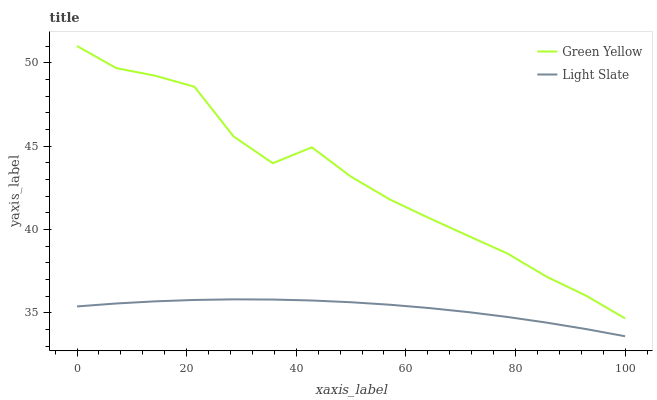Does Light Slate have the minimum area under the curve?
Answer yes or no. Yes. Does Green Yellow have the maximum area under the curve?
Answer yes or no. Yes. Does Green Yellow have the minimum area under the curve?
Answer yes or no. No. Is Light Slate the smoothest?
Answer yes or no. Yes. Is Green Yellow the roughest?
Answer yes or no. Yes. Is Green Yellow the smoothest?
Answer yes or no. No. Does Light Slate have the lowest value?
Answer yes or no. Yes. Does Green Yellow have the lowest value?
Answer yes or no. No. Does Green Yellow have the highest value?
Answer yes or no. Yes. Is Light Slate less than Green Yellow?
Answer yes or no. Yes. Is Green Yellow greater than Light Slate?
Answer yes or no. Yes. Does Light Slate intersect Green Yellow?
Answer yes or no. No. 